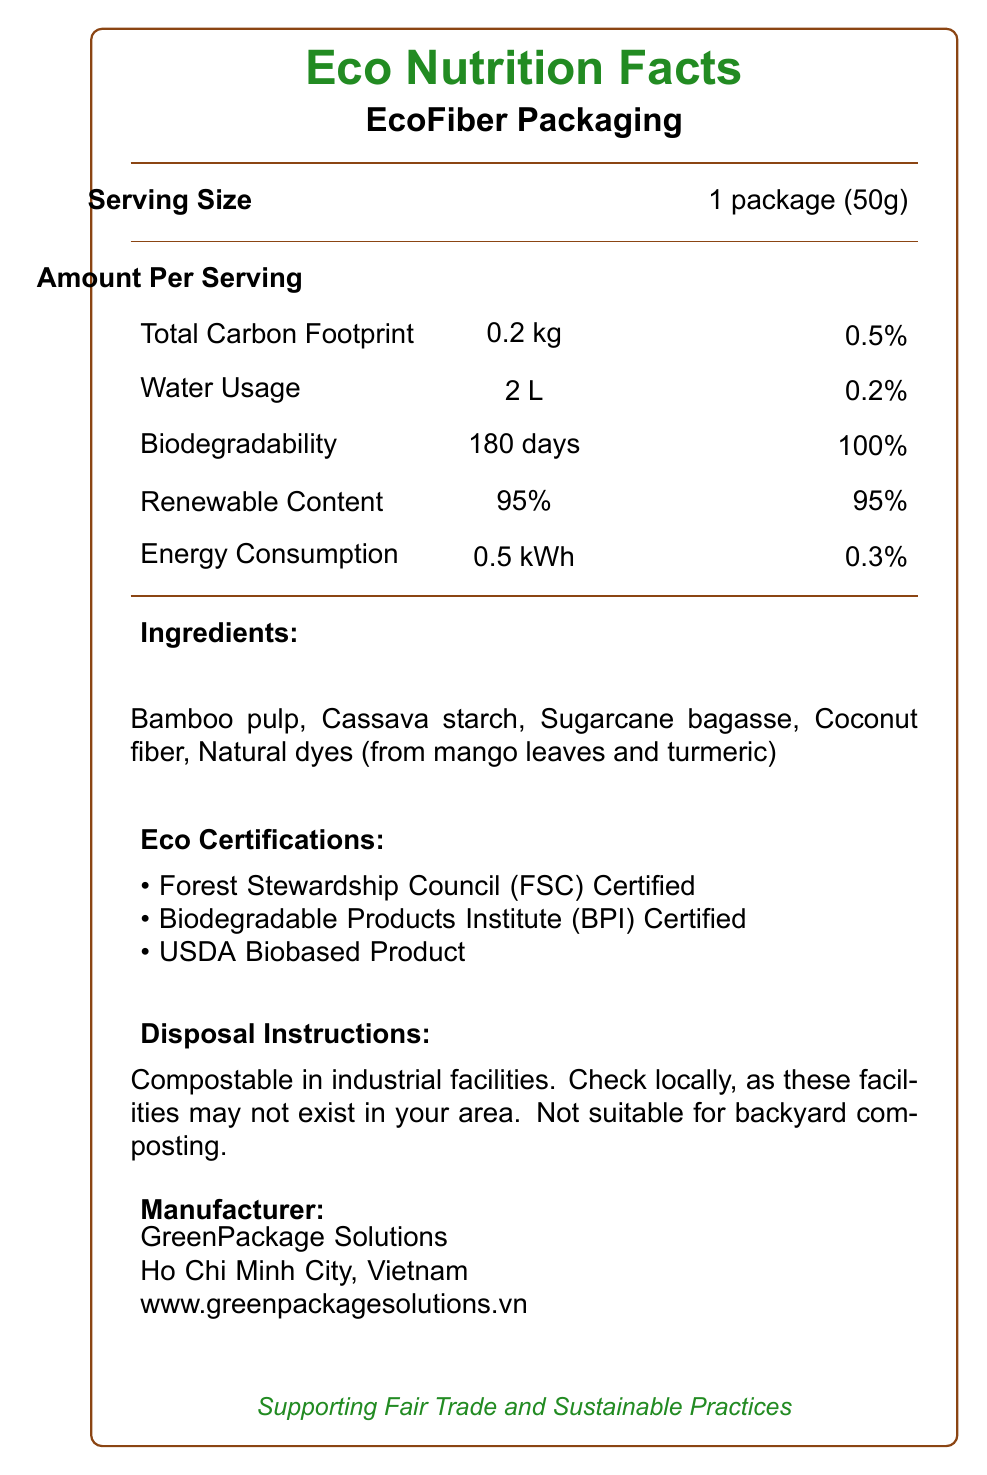What is the serving size for EcoFiber Packaging? The serving size is indicated in the section labeled "Serving Size" as "1 package (50g)".
Answer: 1 package (50g) What ingredients are used in the EcoFiber Packaging? The ingredients are listed under the section labeled "Ingredients:".
Answer: Bamboo pulp, Cassava starch, Sugarcane bagasse, Coconut fiber, Natural dyes (from mango leaves and turmeric) How long does it take for EcoFiber Packaging to biodegrade? The biodegradability is mentioned under the nutrient information section, stating "Biodegradability: 180 days".
Answer: 180 days What is the main eco certification awarded to the EcoFiber Packaging? The document lists three eco certifications: Forest Stewardship Council (FSC) Certified, Biodegradable Products Institute (BPI) Certified, and USDA Biobased Product.
Answer: There are multiple certifications What is the water resistance duration for EcoFiber Packaging? The water resistance feature is listed under "Packaged Features" as "Water Resistance: 4 hours".
Answer: 4 hours How much renewable content does EcoFiber Packaging contain? The renewable content is listed under the nutrient information section as "Renewable Content: 95%".
Answer: 95% Where is the manufacturer of EcoFiber Packaging located? The manufacturer information section states that GreenPackage Solutions is located in Ho Chi Minh City, Vietnam.
Answer: Ho Chi Minh City, Vietnam Which of the following is not an ingredient of the EcoFiber Packaging? A. Bamboo Pulp B. Cassava Starch C. Plastic D. Coconut Fiber The ingredients listed are Bamboo pulp, Cassava starch, Sugarcane bagasse, Coconut fiber, and Natural dyes from mango leaves and turmeric. Plastic is not listed as an ingredient.
Answer: C. Plastic What is the Total Carbon Footprint percentage of the daily value for EcoFiber Packaging? The nutrient information section shows that the Total Carbon Footprint is "0.5%".
Answer: 0.5% Is EcoFiber Packaging suitable for backyard composting? The disposal instructions clearly state "Not suitable for backyard composting".
Answer: No How does the EcoFiber Packaging support fair trade and sustainable practices? The fair trade impact section mentions that 250 jobs have been created, 5 community projects funded, and farmers receive a premium of 15% above market price.
Answer: Jobs created, community projects funded, farmer premium Which of the following does EcoFiber Packaging NOT have? 1. USDA Biobased Product certification 2. Industrial compostable instruction 3. Recyclable plastic 4. Fair trade impact information The document includes USDA Biobased Product certification, industrial compostable instructions, and fair trade impact information. Recyclable plastic is not mentioned.
Answer: 3. Recyclable plastic Summarize the main idea of the document. The document is a comprehensive overview of EcoFiber Packaging, highlighting its sustainable ingredients, reduced environmental impact, various eco-certifications, and fair trade practices supported by the manufacturer.
Answer: The document provides detailed information about EcoFiber Packaging, including its serving size, ingredients, nutrient information related to eco-friendliness, certifications, disposal instructions, fair trade impact, packaging features, sourcing information, carbon offset projects, and manufacturer details. What is the tensile strength of EcoFiber Packaging? The tensile strength is listed under the packaging features section as "Tensile Strength: 2.5 MPa".
Answer: 2.5 MPa What is the name of the manufacturer of the EcoFiber Packaging? The manufacturer information section lists the name as GreenPackage Solutions.
Answer: GreenPackage Solutions How many liters of water are used per package of EcoFiber Packaging? The nutrient information section shows "Water Usage: 2 L".
Answer: 2 L Does the document provide information about the cost of EcoFiber Packaging? The document does not mention any details about the cost of EcoFiber Packaging.
Answer: Not enough information What percentage above market price do farmers receive as a premium for EcoFiber Packaging sourcing? The fair trade impact section states that farmers receive a premium of 15% above market price.
Answer: 15% 